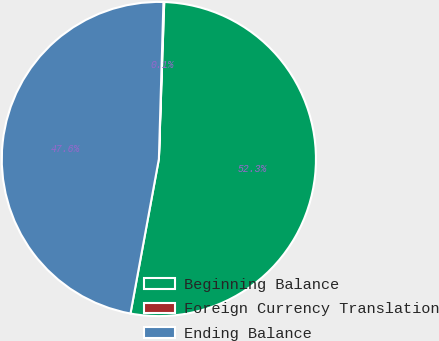Convert chart to OTSL. <chart><loc_0><loc_0><loc_500><loc_500><pie_chart><fcel>Beginning Balance<fcel>Foreign Currency Translation<fcel>Ending Balance<nl><fcel>52.35%<fcel>0.08%<fcel>47.57%<nl></chart> 